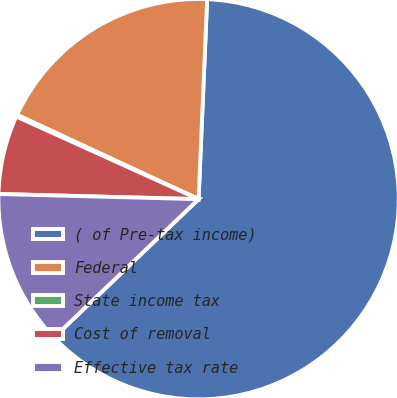Convert chart to OTSL. <chart><loc_0><loc_0><loc_500><loc_500><pie_chart><fcel>( of Pre-tax income)<fcel>Federal<fcel>State income tax<fcel>Cost of removal<fcel>Effective tax rate<nl><fcel>62.17%<fcel>18.76%<fcel>0.15%<fcel>6.36%<fcel>12.56%<nl></chart> 